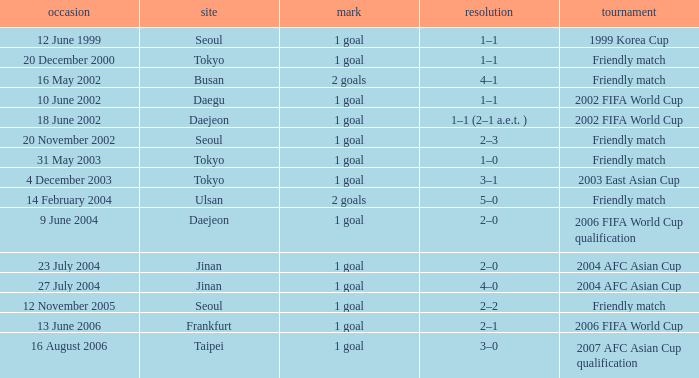What is the venue for the event on 12 November 2005? Seoul. 